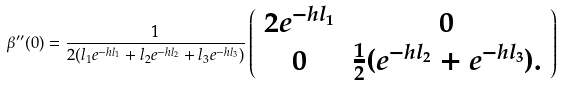<formula> <loc_0><loc_0><loc_500><loc_500>\beta ^ { \prime \prime } ( 0 ) = \frac { 1 } { 2 ( l _ { 1 } e ^ { - h l _ { 1 } } + l _ { 2 } e ^ { - h l _ { 2 } } + l _ { 3 } e ^ { - h l _ { 3 } } ) } \left ( \begin{array} { c c } 2 e ^ { - h l _ { 1 } } & 0 \\ 0 & \frac { 1 } { 2 } ( e ^ { - h l _ { 2 } } + e ^ { - h l _ { 3 } } ) . \\ \end{array} \right )</formula> 